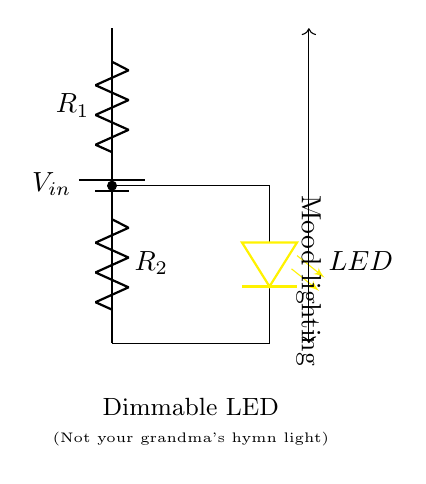What type of circuit is shown? The circuit is a voltage divider, which consists of two resistors in series that divide the input voltage.
Answer: Voltage divider What components are used in the circuit? The components in the circuit include a battery, resistors, and an LED.
Answer: Battery, resistors, LED What is the purpose of the resistors? The resistors reduce the voltage applied to the LED, allowing it to dim by controlling the current flowing through it.
Answer: To dim the LED How many resistors are in the circuit? There are two resistors in the circuit, labeled as R1 and R2.
Answer: Two What connects the LED to the battery? The LED is connected in parallel with the second resistor (R2) in the circuit.
Answer: R2 If R1 is 220 ohms and R2 is 470 ohms, what is the total resistance? The total resistance in a series circuit is simply the sum of the individual resistances: R1 + R2 = 220 + 470 = 690 ohms.
Answer: 690 ohms What will happen if the value of R2 is increased? Increasing R2 will result in a higher voltage drop across it, decreasing the current through the LED, which will make the LED dimmer.
Answer: LED dims 